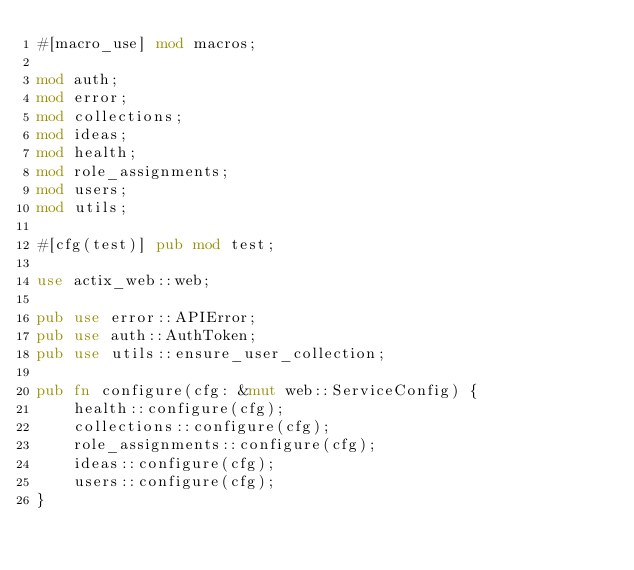Convert code to text. <code><loc_0><loc_0><loc_500><loc_500><_Rust_>#[macro_use] mod macros;

mod auth;
mod error;
mod collections;
mod ideas;
mod health;
mod role_assignments;
mod users;
mod utils;

#[cfg(test)] pub mod test;

use actix_web::web;

pub use error::APIError;
pub use auth::AuthToken;
pub use utils::ensure_user_collection;

pub fn configure(cfg: &mut web::ServiceConfig) {
    health::configure(cfg);
    collections::configure(cfg);
    role_assignments::configure(cfg);
    ideas::configure(cfg);
    users::configure(cfg);
}</code> 